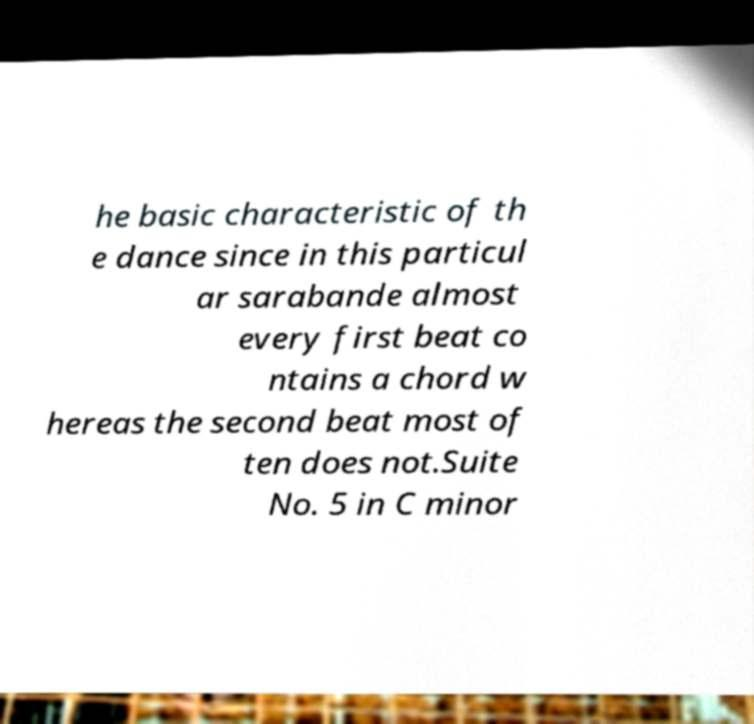Could you extract and type out the text from this image? he basic characteristic of th e dance since in this particul ar sarabande almost every first beat co ntains a chord w hereas the second beat most of ten does not.Suite No. 5 in C minor 